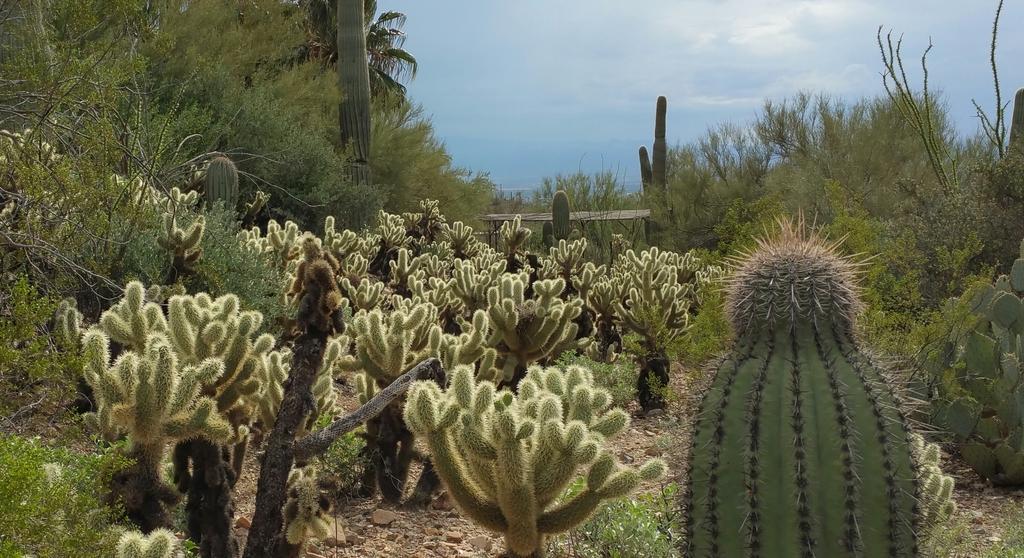How would you summarize this image in a sentence or two? In this image I can see few plants which are green in color and I can see number of spikes to them. I can see the ground, few stones and few trees. In the background I can see the sky. 